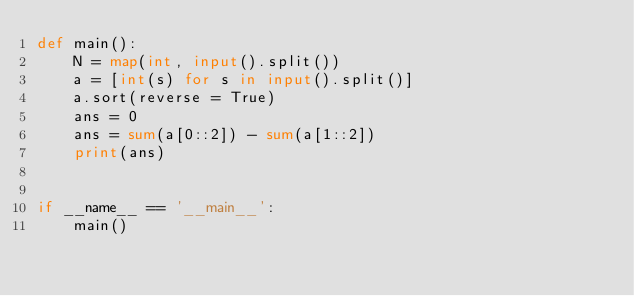Convert code to text. <code><loc_0><loc_0><loc_500><loc_500><_Python_>def main():
    N = map(int, input().split())
    a = [int(s) for s in input().split()]
    a.sort(reverse = True)
    ans = 0
    ans = sum(a[0::2]) - sum(a[1::2])
    print(ans)


if __name__ == '__main__':
    main()
</code> 